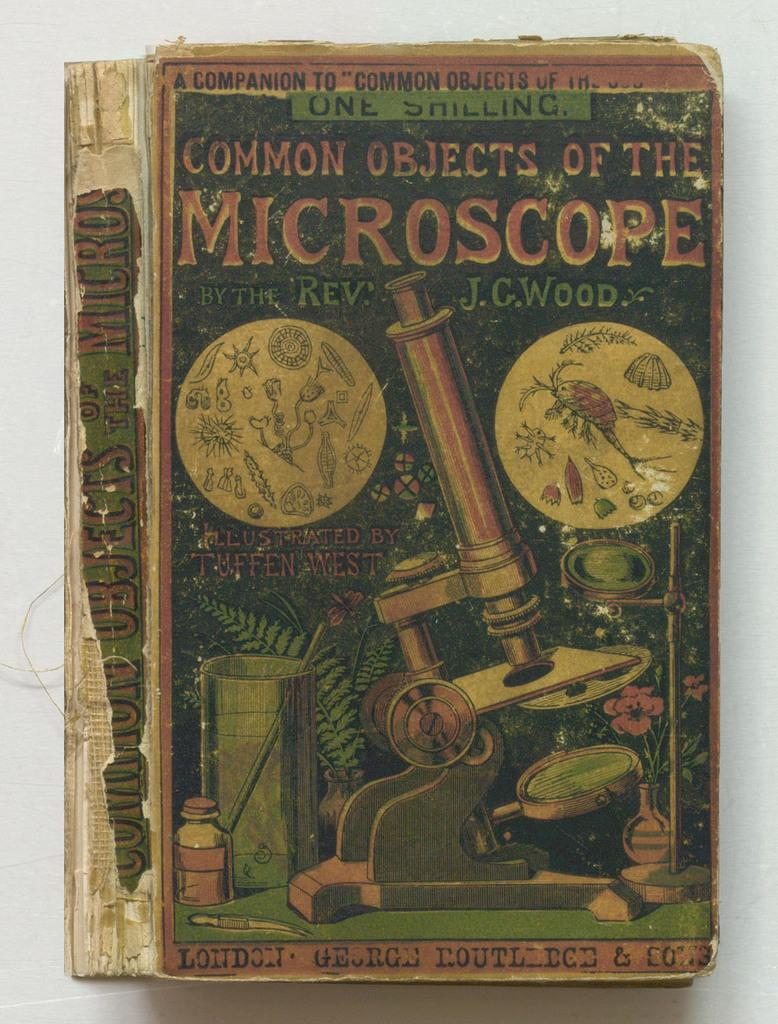<image>
Render a clear and concise summary of the photo. Common Objects of the Microscope was written by the Rev. J.G. Wood 